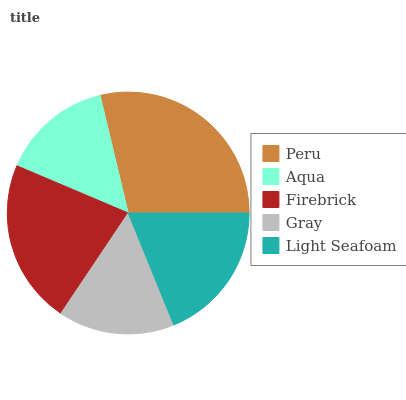Is Aqua the minimum?
Answer yes or no. Yes. Is Peru the maximum?
Answer yes or no. Yes. Is Firebrick the minimum?
Answer yes or no. No. Is Firebrick the maximum?
Answer yes or no. No. Is Firebrick greater than Aqua?
Answer yes or no. Yes. Is Aqua less than Firebrick?
Answer yes or no. Yes. Is Aqua greater than Firebrick?
Answer yes or no. No. Is Firebrick less than Aqua?
Answer yes or no. No. Is Light Seafoam the high median?
Answer yes or no. Yes. Is Light Seafoam the low median?
Answer yes or no. Yes. Is Firebrick the high median?
Answer yes or no. No. Is Firebrick the low median?
Answer yes or no. No. 